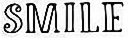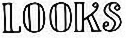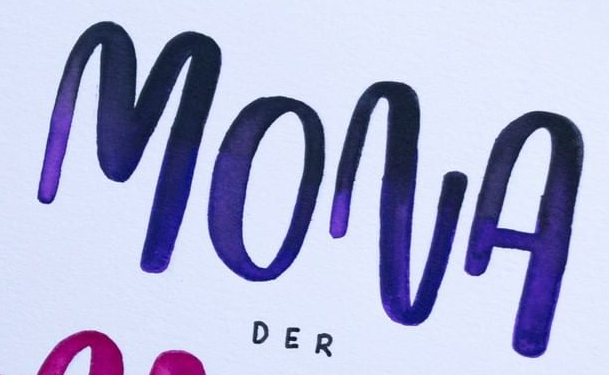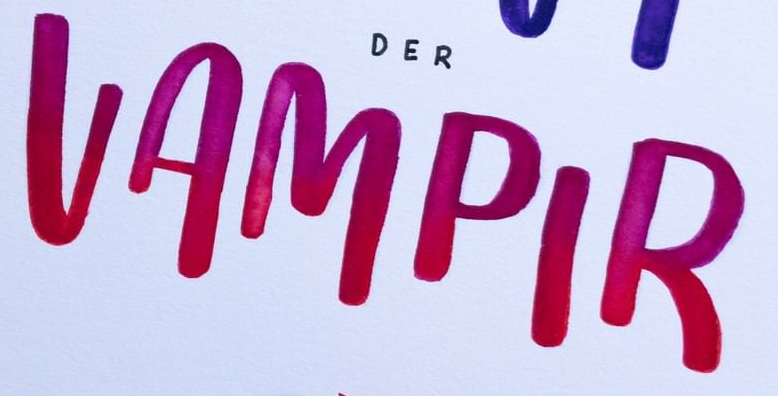Transcribe the words shown in these images in order, separated by a semicolon. SMILE; LOOKS; MONA; VAMPIR 